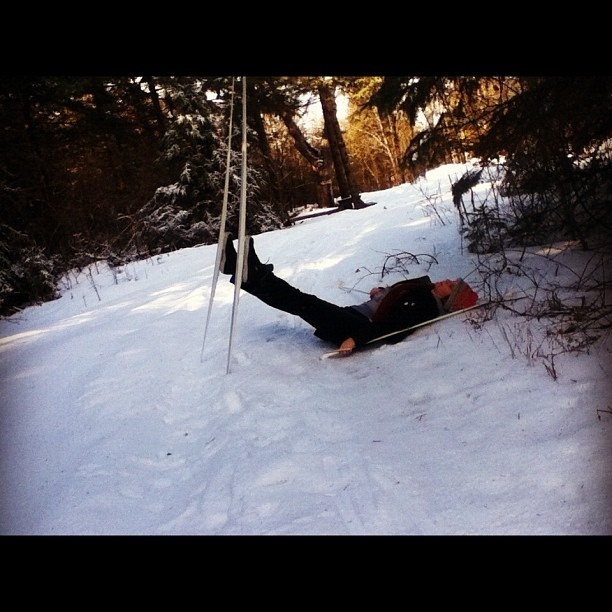Describe the objects in this image and their specific colors. I can see people in black, maroon, gray, and darkgray tones and skis in black, darkgray, and gray tones in this image. 